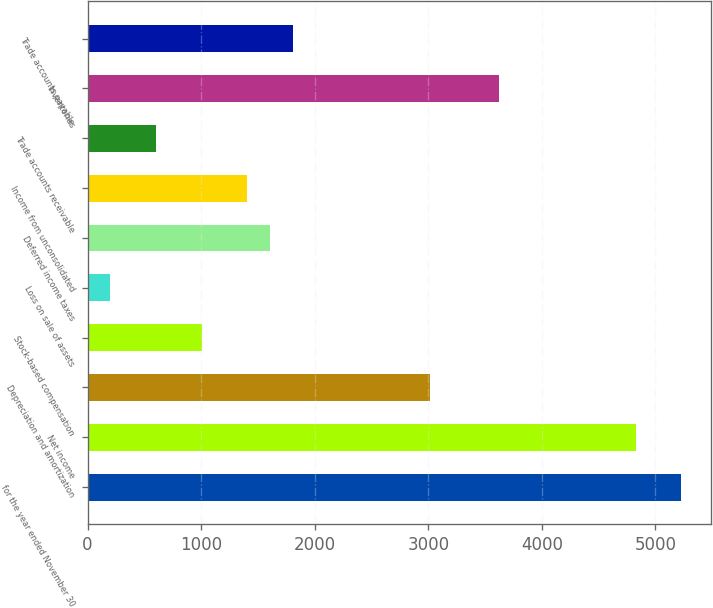<chart> <loc_0><loc_0><loc_500><loc_500><bar_chart><fcel>for the year ended November 30<fcel>Net income<fcel>Depreciation and amortization<fcel>Stock-based compensation<fcel>Loss on sale of assets<fcel>Deferred income taxes<fcel>Income from unconsolidated<fcel>Trade accounts receivable<fcel>Inventories<fcel>Trade accounts payable<nl><fcel>5227.64<fcel>4825.56<fcel>3016.2<fcel>1005.8<fcel>201.64<fcel>1608.92<fcel>1407.88<fcel>603.72<fcel>3619.32<fcel>1809.96<nl></chart> 